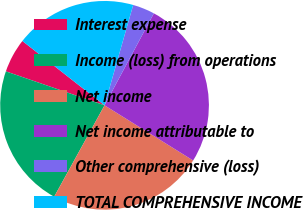<chart> <loc_0><loc_0><loc_500><loc_500><pie_chart><fcel>Interest expense<fcel>Income (loss) from operations<fcel>Net income<fcel>Net income attributable to<fcel>Other comprehensive (loss)<fcel>TOTAL COMPREHENSIVE INCOME<nl><fcel>5.3%<fcel>22.26%<fcel>24.15%<fcel>26.03%<fcel>3.41%<fcel>18.85%<nl></chart> 